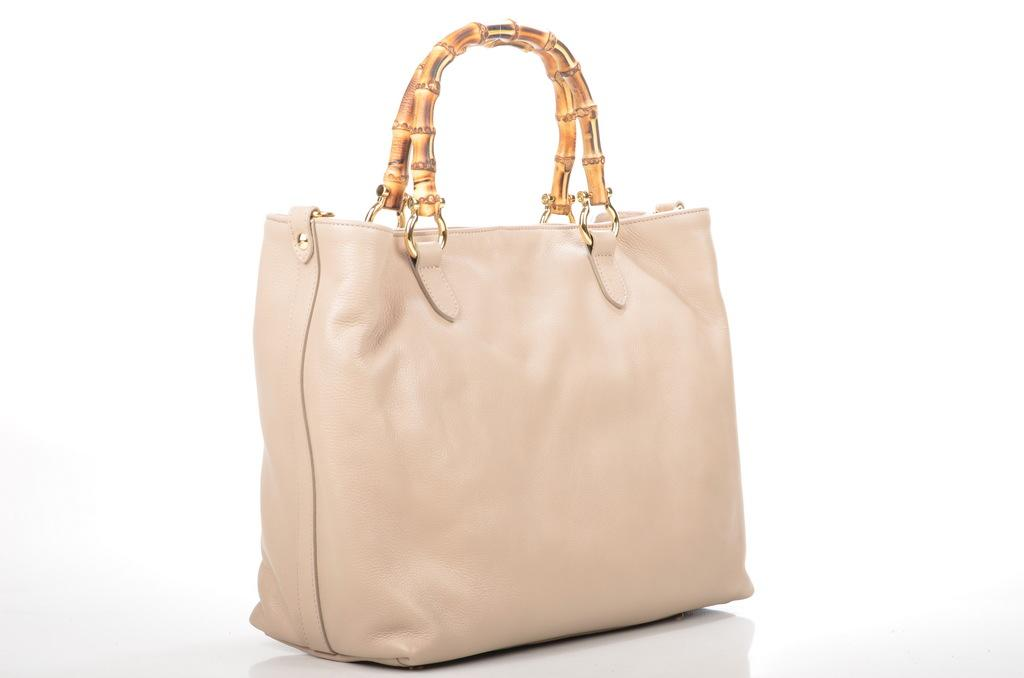What type of accessory is visible in the image? There is a ladies handbag in the image. Can you describe the handbag in more detail? Unfortunately, the image only shows the handbag, and no further details are provided. What type of hammer is being used to fix the teeth in the image? There is no hammer or teeth present in the image; it only features a ladies handbag. 